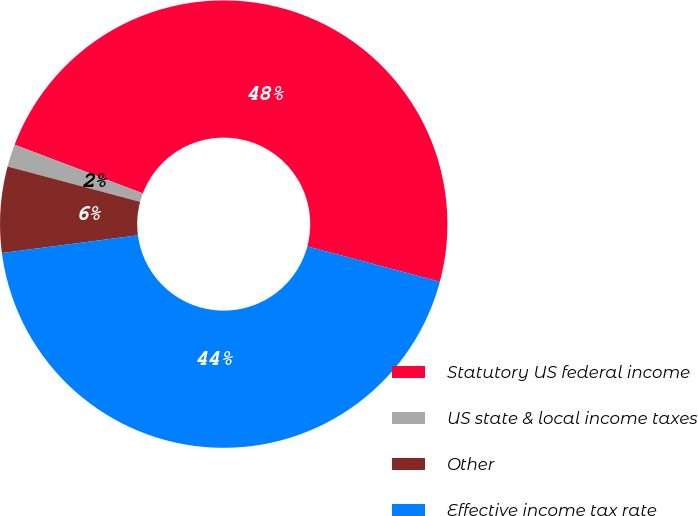<chart> <loc_0><loc_0><loc_500><loc_500><pie_chart><fcel>Statutory US federal income<fcel>US state & local income taxes<fcel>Other<fcel>Effective income tax rate<nl><fcel>48.37%<fcel>1.63%<fcel>6.21%<fcel>43.79%<nl></chart> 